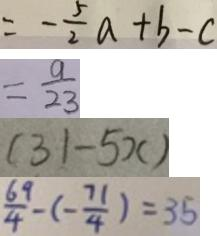<formula> <loc_0><loc_0><loc_500><loc_500>= - \frac { 5 } { 2 } a + b - c 
 = \frac { 9 } { 2 3 } 
 ( 3 1 - 5 x ) 
 \frac { 6 9 } { 4 } - ( - \frac { 7 1 } { 4 } ) = 3 5</formula> 